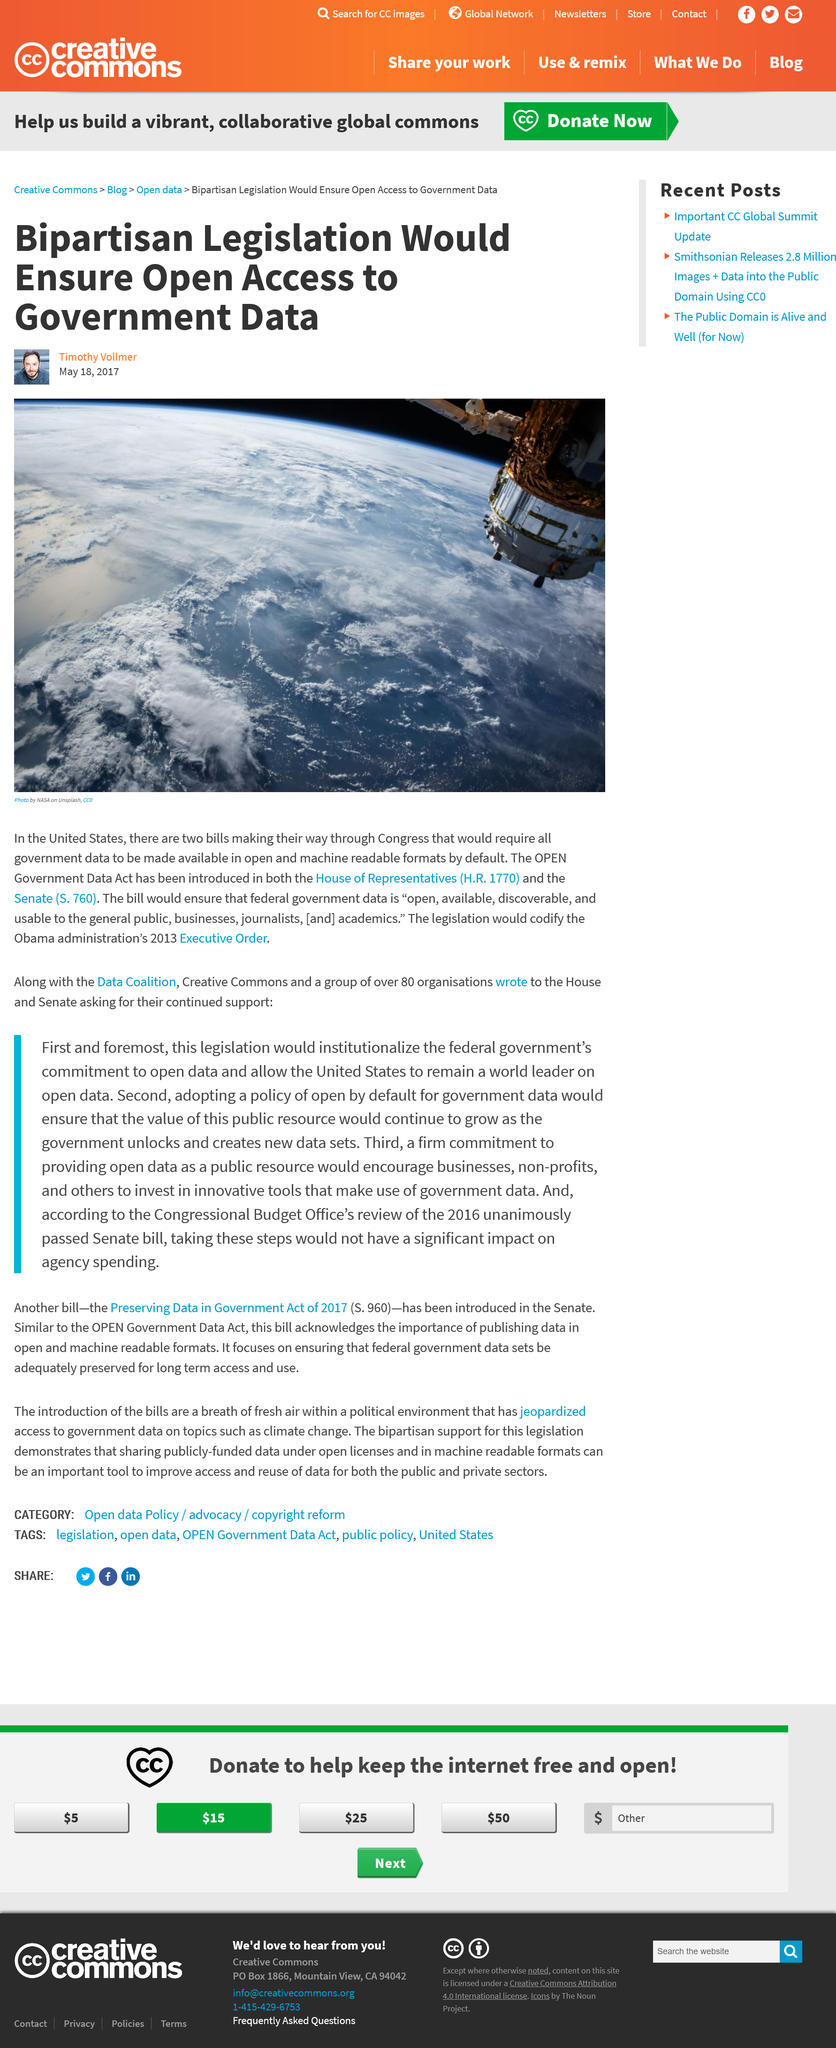Highlight a few significant elements in this photo. This article was published in 2017, as stated in the article. The author of this article is Timothy Vollmer. The image shows a planet that is not Earth, and Earth is depicted in the photograph. 